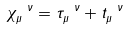<formula> <loc_0><loc_0><loc_500><loc_500>\chi _ { \mu } ^ { \ \nu } = \tau _ { \mu } ^ { \ \nu } + t _ { \mu } ^ { \ \nu }</formula> 